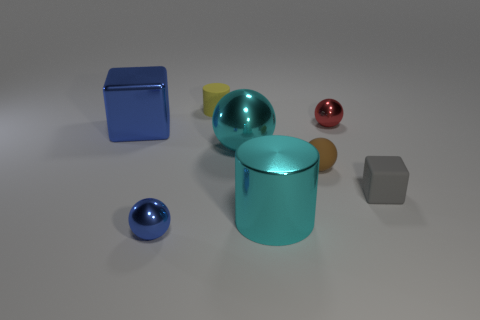Subtract all blue metallic balls. How many balls are left? 3 Add 2 tiny red metal balls. How many objects exist? 10 Subtract all yellow cylinders. How many cylinders are left? 1 Subtract 0 brown cylinders. How many objects are left? 8 Subtract all cylinders. How many objects are left? 6 Subtract 1 cylinders. How many cylinders are left? 1 Subtract all yellow balls. Subtract all blue cubes. How many balls are left? 4 Subtract all tiny green shiny cylinders. Subtract all small gray matte cubes. How many objects are left? 7 Add 2 yellow things. How many yellow things are left? 3 Add 1 tiny green balls. How many tiny green balls exist? 1 